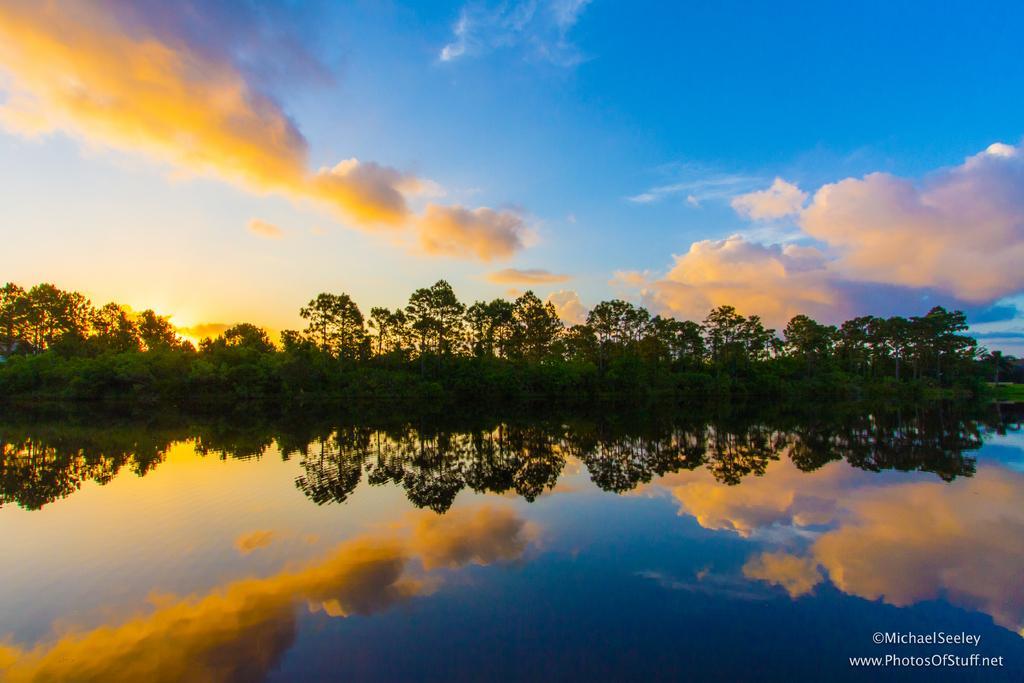How would you summarize this image in a sentence or two? In this image, we can see trees. At the bottom, there is water and we can see some text. At the top, there is sunlight and there are clouds in the sky. 